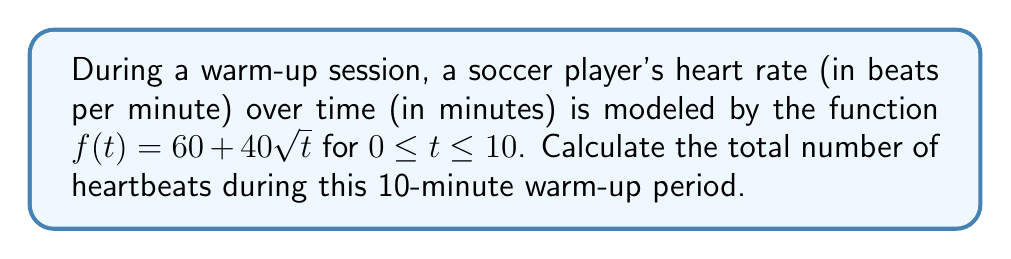Help me with this question. To solve this problem, we need to find the area under the curve of the heart rate function over the given time interval. This can be done using definite integration.

1. Set up the definite integral:
   $$\int_0^{10} (60 + 40\sqrt{t}) dt$$

2. Split the integral:
   $$\int_0^{10} 60 dt + \int_0^{10} 40\sqrt{t} dt$$

3. Integrate the constant term:
   $$60t \Big|_0^{10} + \int_0^{10} 40\sqrt{t} dt$$

4. For the second integral, use the power rule with $u$-substitution:
   Let $u = \sqrt{t}$, then $t = u^2$ and $dt = 2u du$
   $$60t \Big|_0^{10} + 40 \int_0^{\sqrt{10}} u \cdot 2u du$$
   $$60t \Big|_0^{10} + 80 \int_0^{\sqrt{10}} u^2 du$$

5. Integrate:
   $$60t \Big|_0^{10} + 80 \cdot \frac{u^3}{3} \Big|_0^{\sqrt{10}}$$

6. Evaluate the definite integrals:
   $$[60 \cdot 10 - 60 \cdot 0] + 80 \cdot [\frac{(\sqrt{10})^3}{3} - \frac{0^3}{3}]$$
   $$600 + 80 \cdot \frac{10\sqrt{10}}{3}$$

7. Simplify:
   $$600 + \frac{800\sqrt{10}}{3}$$

This result represents the area under the curve, which is equivalent to the total number of heartbeats during the 10-minute warm-up period.
Answer: $600 + \frac{800\sqrt{10}}{3}$ heartbeats 